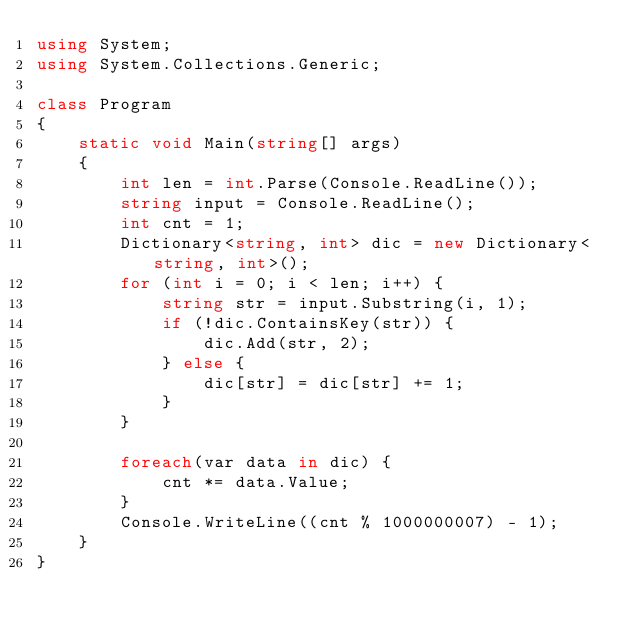Convert code to text. <code><loc_0><loc_0><loc_500><loc_500><_C#_>using System;
using System.Collections.Generic;

class Program
{
    static void Main(string[] args)
    {
        int len = int.Parse(Console.ReadLine());
        string input = Console.ReadLine();
        int cnt = 1;
        Dictionary<string, int> dic = new Dictionary<string, int>();
        for (int i = 0; i < len; i++) {
            string str = input.Substring(i, 1);
            if (!dic.ContainsKey(str)) {
                dic.Add(str, 2);
            } else {
                dic[str] = dic[str] += 1;
            }
        }

        foreach(var data in dic) {
            cnt *= data.Value;
        }
        Console.WriteLine((cnt % 1000000007) - 1);
    }
}

</code> 